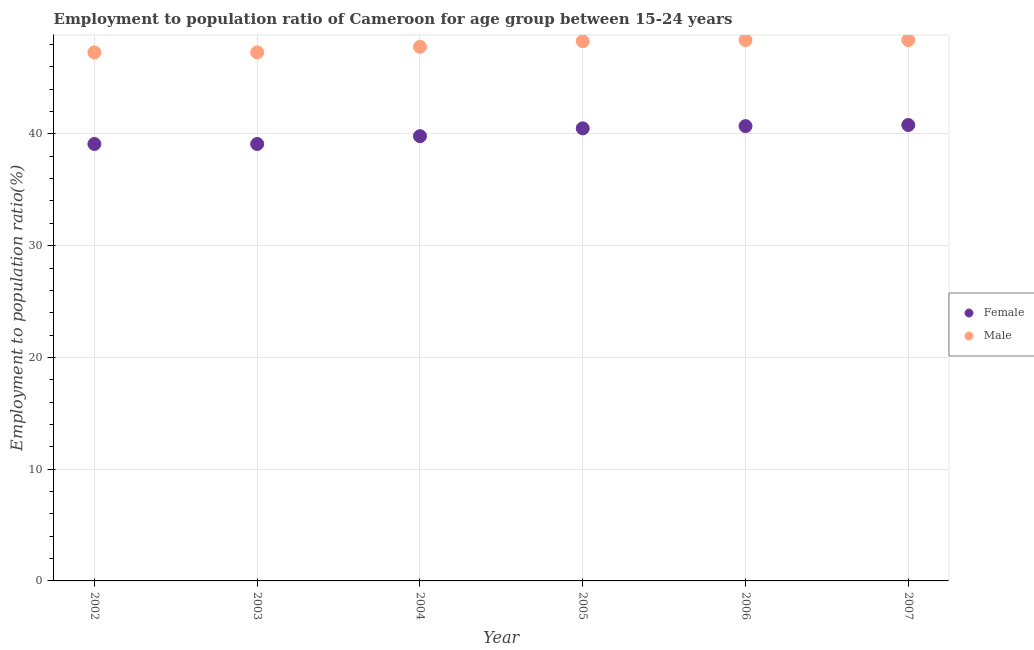Is the number of dotlines equal to the number of legend labels?
Ensure brevity in your answer.  Yes. What is the employment to population ratio(male) in 2005?
Make the answer very short. 48.3. Across all years, what is the maximum employment to population ratio(female)?
Provide a short and direct response. 40.8. Across all years, what is the minimum employment to population ratio(male)?
Your answer should be compact. 47.3. In which year was the employment to population ratio(female) maximum?
Offer a terse response. 2007. What is the total employment to population ratio(male) in the graph?
Offer a terse response. 287.5. What is the difference between the employment to population ratio(female) in 2002 and that in 2007?
Give a very brief answer. -1.7. What is the difference between the employment to population ratio(male) in 2003 and the employment to population ratio(female) in 2005?
Keep it short and to the point. 6.8. What is the average employment to population ratio(female) per year?
Offer a very short reply. 40. What is the ratio of the employment to population ratio(female) in 2003 to that in 2006?
Your answer should be very brief. 0.96. Is the difference between the employment to population ratio(female) in 2002 and 2004 greater than the difference between the employment to population ratio(male) in 2002 and 2004?
Your answer should be compact. No. What is the difference between the highest and the second highest employment to population ratio(female)?
Offer a very short reply. 0.1. What is the difference between the highest and the lowest employment to population ratio(female)?
Make the answer very short. 1.7. In how many years, is the employment to population ratio(female) greater than the average employment to population ratio(female) taken over all years?
Your answer should be compact. 3. Is the sum of the employment to population ratio(male) in 2003 and 2005 greater than the maximum employment to population ratio(female) across all years?
Ensure brevity in your answer.  Yes. Is the employment to population ratio(female) strictly greater than the employment to population ratio(male) over the years?
Provide a succinct answer. No. Is the employment to population ratio(female) strictly less than the employment to population ratio(male) over the years?
Make the answer very short. Yes. How many dotlines are there?
Keep it short and to the point. 2. How many years are there in the graph?
Offer a very short reply. 6. What is the difference between two consecutive major ticks on the Y-axis?
Offer a terse response. 10. Are the values on the major ticks of Y-axis written in scientific E-notation?
Your answer should be compact. No. Does the graph contain any zero values?
Provide a succinct answer. No. Where does the legend appear in the graph?
Make the answer very short. Center right. How are the legend labels stacked?
Offer a terse response. Vertical. What is the title of the graph?
Offer a terse response. Employment to population ratio of Cameroon for age group between 15-24 years. What is the label or title of the X-axis?
Offer a very short reply. Year. What is the Employment to population ratio(%) in Female in 2002?
Your answer should be compact. 39.1. What is the Employment to population ratio(%) in Male in 2002?
Your answer should be very brief. 47.3. What is the Employment to population ratio(%) in Female in 2003?
Offer a terse response. 39.1. What is the Employment to population ratio(%) in Male in 2003?
Offer a very short reply. 47.3. What is the Employment to population ratio(%) in Female in 2004?
Make the answer very short. 39.8. What is the Employment to population ratio(%) of Male in 2004?
Your answer should be very brief. 47.8. What is the Employment to population ratio(%) in Female in 2005?
Your answer should be very brief. 40.5. What is the Employment to population ratio(%) of Male in 2005?
Keep it short and to the point. 48.3. What is the Employment to population ratio(%) in Female in 2006?
Offer a very short reply. 40.7. What is the Employment to population ratio(%) in Male in 2006?
Give a very brief answer. 48.4. What is the Employment to population ratio(%) in Female in 2007?
Your answer should be compact. 40.8. What is the Employment to population ratio(%) of Male in 2007?
Give a very brief answer. 48.4. Across all years, what is the maximum Employment to population ratio(%) in Female?
Make the answer very short. 40.8. Across all years, what is the maximum Employment to population ratio(%) in Male?
Make the answer very short. 48.4. Across all years, what is the minimum Employment to population ratio(%) of Female?
Give a very brief answer. 39.1. Across all years, what is the minimum Employment to population ratio(%) of Male?
Your answer should be very brief. 47.3. What is the total Employment to population ratio(%) in Female in the graph?
Your answer should be compact. 240. What is the total Employment to population ratio(%) of Male in the graph?
Offer a very short reply. 287.5. What is the difference between the Employment to population ratio(%) of Female in 2002 and that in 2003?
Your answer should be compact. 0. What is the difference between the Employment to population ratio(%) in Male in 2002 and that in 2003?
Ensure brevity in your answer.  0. What is the difference between the Employment to population ratio(%) in Male in 2002 and that in 2004?
Provide a short and direct response. -0.5. What is the difference between the Employment to population ratio(%) of Female in 2002 and that in 2005?
Offer a terse response. -1.4. What is the difference between the Employment to population ratio(%) of Male in 2002 and that in 2005?
Offer a very short reply. -1. What is the difference between the Employment to population ratio(%) of Female in 2002 and that in 2007?
Offer a very short reply. -1.7. What is the difference between the Employment to population ratio(%) of Male in 2002 and that in 2007?
Your answer should be very brief. -1.1. What is the difference between the Employment to population ratio(%) in Female in 2003 and that in 2005?
Keep it short and to the point. -1.4. What is the difference between the Employment to population ratio(%) in Female in 2003 and that in 2006?
Your answer should be compact. -1.6. What is the difference between the Employment to population ratio(%) in Male in 2003 and that in 2006?
Make the answer very short. -1.1. What is the difference between the Employment to population ratio(%) in Female in 2003 and that in 2007?
Provide a succinct answer. -1.7. What is the difference between the Employment to population ratio(%) of Female in 2004 and that in 2005?
Your answer should be compact. -0.7. What is the difference between the Employment to population ratio(%) of Male in 2005 and that in 2006?
Your answer should be compact. -0.1. What is the difference between the Employment to population ratio(%) of Female in 2006 and that in 2007?
Make the answer very short. -0.1. What is the difference between the Employment to population ratio(%) of Male in 2006 and that in 2007?
Keep it short and to the point. 0. What is the difference between the Employment to population ratio(%) in Female in 2002 and the Employment to population ratio(%) in Male in 2003?
Your answer should be very brief. -8.2. What is the difference between the Employment to population ratio(%) in Female in 2002 and the Employment to population ratio(%) in Male in 2005?
Give a very brief answer. -9.2. What is the difference between the Employment to population ratio(%) in Female in 2002 and the Employment to population ratio(%) in Male in 2006?
Provide a succinct answer. -9.3. What is the difference between the Employment to population ratio(%) in Female in 2002 and the Employment to population ratio(%) in Male in 2007?
Ensure brevity in your answer.  -9.3. What is the difference between the Employment to population ratio(%) of Female in 2003 and the Employment to population ratio(%) of Male in 2004?
Provide a short and direct response. -8.7. What is the difference between the Employment to population ratio(%) in Female in 2003 and the Employment to population ratio(%) in Male in 2005?
Your answer should be compact. -9.2. What is the difference between the Employment to population ratio(%) in Female in 2003 and the Employment to population ratio(%) in Male in 2006?
Keep it short and to the point. -9.3. What is the difference between the Employment to population ratio(%) in Female in 2006 and the Employment to population ratio(%) in Male in 2007?
Your answer should be very brief. -7.7. What is the average Employment to population ratio(%) in Male per year?
Keep it short and to the point. 47.92. In the year 2002, what is the difference between the Employment to population ratio(%) of Female and Employment to population ratio(%) of Male?
Offer a terse response. -8.2. In the year 2005, what is the difference between the Employment to population ratio(%) in Female and Employment to population ratio(%) in Male?
Provide a succinct answer. -7.8. In the year 2006, what is the difference between the Employment to population ratio(%) in Female and Employment to population ratio(%) in Male?
Make the answer very short. -7.7. What is the ratio of the Employment to population ratio(%) in Female in 2002 to that in 2003?
Ensure brevity in your answer.  1. What is the ratio of the Employment to population ratio(%) in Female in 2002 to that in 2004?
Provide a succinct answer. 0.98. What is the ratio of the Employment to population ratio(%) of Male in 2002 to that in 2004?
Offer a very short reply. 0.99. What is the ratio of the Employment to population ratio(%) of Female in 2002 to that in 2005?
Your response must be concise. 0.97. What is the ratio of the Employment to population ratio(%) in Male in 2002 to that in 2005?
Provide a succinct answer. 0.98. What is the ratio of the Employment to population ratio(%) of Female in 2002 to that in 2006?
Offer a very short reply. 0.96. What is the ratio of the Employment to population ratio(%) in Male in 2002 to that in 2006?
Offer a terse response. 0.98. What is the ratio of the Employment to population ratio(%) in Female in 2002 to that in 2007?
Provide a short and direct response. 0.96. What is the ratio of the Employment to population ratio(%) of Male in 2002 to that in 2007?
Provide a succinct answer. 0.98. What is the ratio of the Employment to population ratio(%) of Female in 2003 to that in 2004?
Make the answer very short. 0.98. What is the ratio of the Employment to population ratio(%) in Male in 2003 to that in 2004?
Your answer should be compact. 0.99. What is the ratio of the Employment to population ratio(%) in Female in 2003 to that in 2005?
Offer a terse response. 0.97. What is the ratio of the Employment to population ratio(%) of Male in 2003 to that in 2005?
Offer a terse response. 0.98. What is the ratio of the Employment to population ratio(%) of Female in 2003 to that in 2006?
Your answer should be compact. 0.96. What is the ratio of the Employment to population ratio(%) in Male in 2003 to that in 2006?
Ensure brevity in your answer.  0.98. What is the ratio of the Employment to population ratio(%) of Male in 2003 to that in 2007?
Give a very brief answer. 0.98. What is the ratio of the Employment to population ratio(%) of Female in 2004 to that in 2005?
Ensure brevity in your answer.  0.98. What is the ratio of the Employment to population ratio(%) of Female in 2004 to that in 2006?
Your answer should be very brief. 0.98. What is the ratio of the Employment to population ratio(%) of Male in 2004 to that in 2006?
Ensure brevity in your answer.  0.99. What is the ratio of the Employment to population ratio(%) of Female in 2004 to that in 2007?
Provide a succinct answer. 0.98. What is the ratio of the Employment to population ratio(%) of Male in 2004 to that in 2007?
Your answer should be very brief. 0.99. What is the ratio of the Employment to population ratio(%) of Male in 2005 to that in 2006?
Your answer should be very brief. 1. What is the ratio of the Employment to population ratio(%) of Male in 2005 to that in 2007?
Provide a succinct answer. 1. What is the ratio of the Employment to population ratio(%) of Female in 2006 to that in 2007?
Provide a short and direct response. 1. What is the difference between the highest and the second highest Employment to population ratio(%) in Female?
Provide a succinct answer. 0.1. What is the difference between the highest and the second highest Employment to population ratio(%) of Male?
Your answer should be compact. 0. 